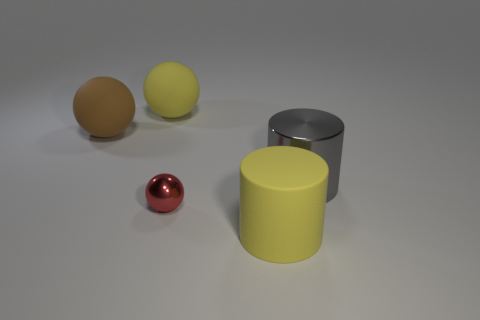Add 2 big gray cylinders. How many objects exist? 7 Subtract all cylinders. How many objects are left? 3 Subtract 0 brown blocks. How many objects are left? 5 Subtract all tiny red metal spheres. Subtract all large brown balls. How many objects are left? 3 Add 1 large brown matte things. How many large brown matte things are left? 2 Add 1 brown rubber spheres. How many brown rubber spheres exist? 2 